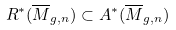Convert formula to latex. <formula><loc_0><loc_0><loc_500><loc_500>R ^ { * } ( \overline { M } _ { g , n } ) \subset A ^ { * } ( \overline { M } _ { g , n } )</formula> 